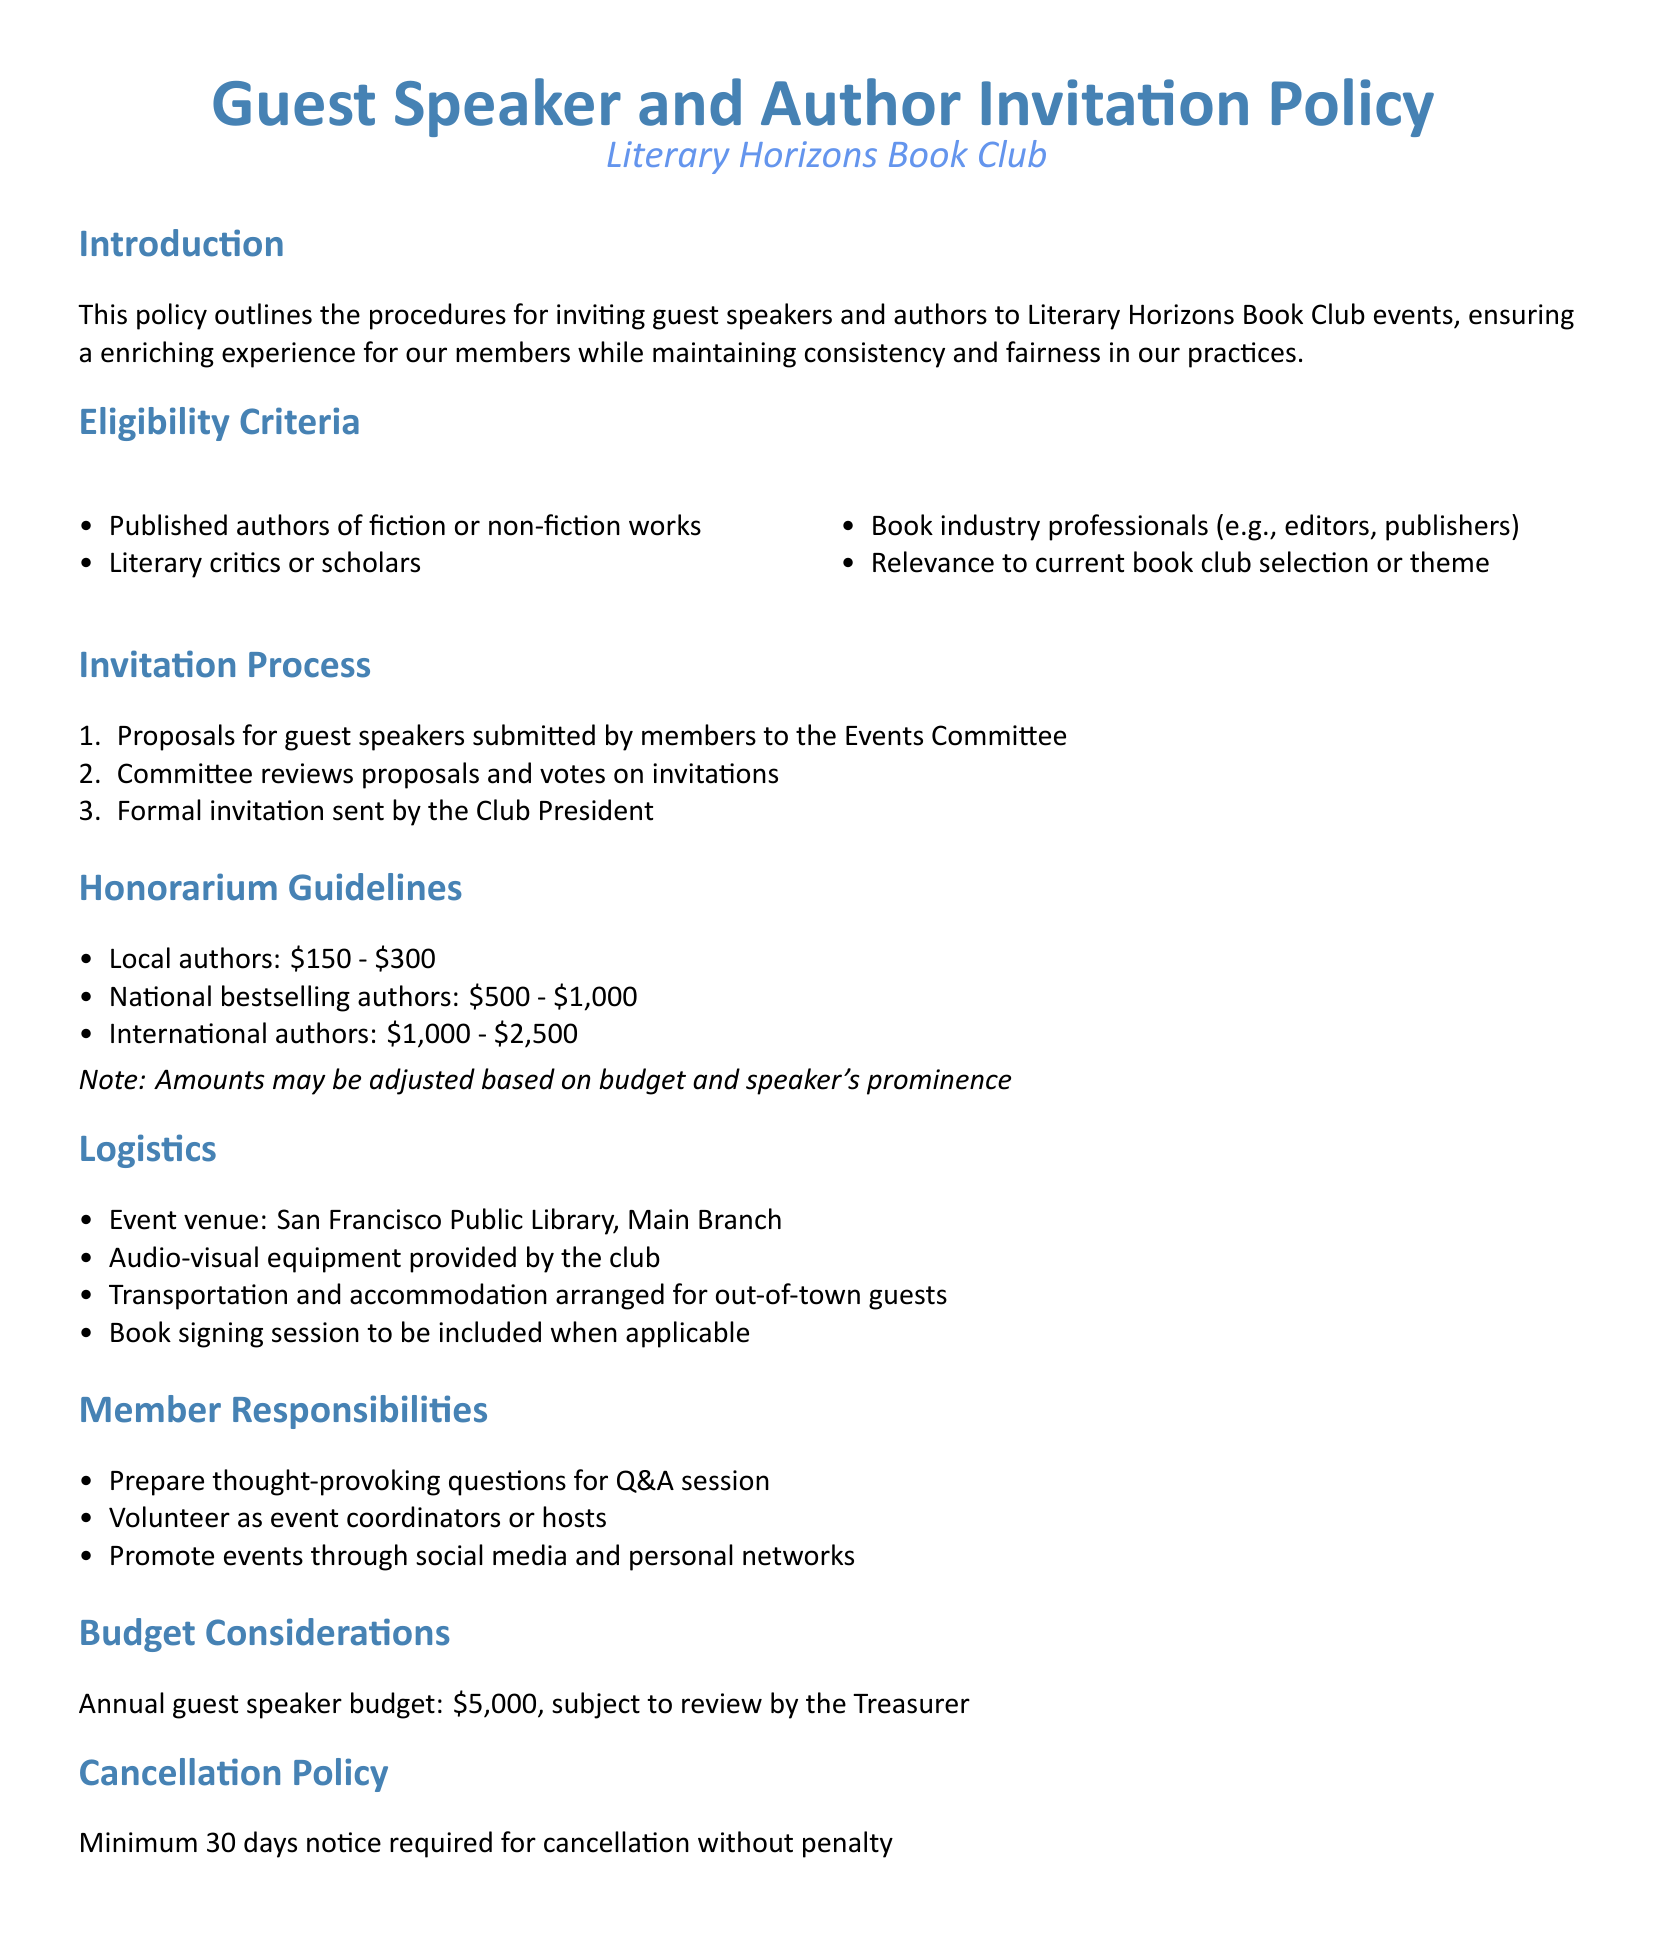What is the minimum honorarium for local authors? The document specifies the range of honorarium for local authors, which is between $150 and $300.
Answer: $150 How many days notice is required for cancellation without penalty? The cancellation policy in the document states a minimum of 30 days notice is required for cancellation without penalty.
Answer: 30 What is the venue for events? The logistics section of the document mentions that events are held at the San Francisco Public Library, Main Branch.
Answer: San Francisco Public Library, Main Branch What is the annual budget for guest speakers? The document indicates that the annual guest speaker budget is $5,000.
Answer: $5,000 Who sends the formal invitation to the guest speakers? The invitation process states that the Club President sends the formal invitation after the Events Committee's review.
Answer: Club President What types of professionals are eligible to be invited as speakers? The eligibility criteria list includes published authors, literary critics, scholars, and book industry professionals.
Answer: Published authors, literary critics, scholars, book industry professionals What is included in the logistics for out-of-town guests? The logistics section mentions that transportation and accommodation are arranged for out-of-town guests.
Answer: Transportation and accommodation How are proposals for guest speakers submitted? Proposals for guest speakers must be submitted by members to the Events Committee.
Answer: Submitted by members to the Events Committee What additional activity is included when applicable? The logistics section states that a book signing session is included when applicable.
Answer: Book signing session 